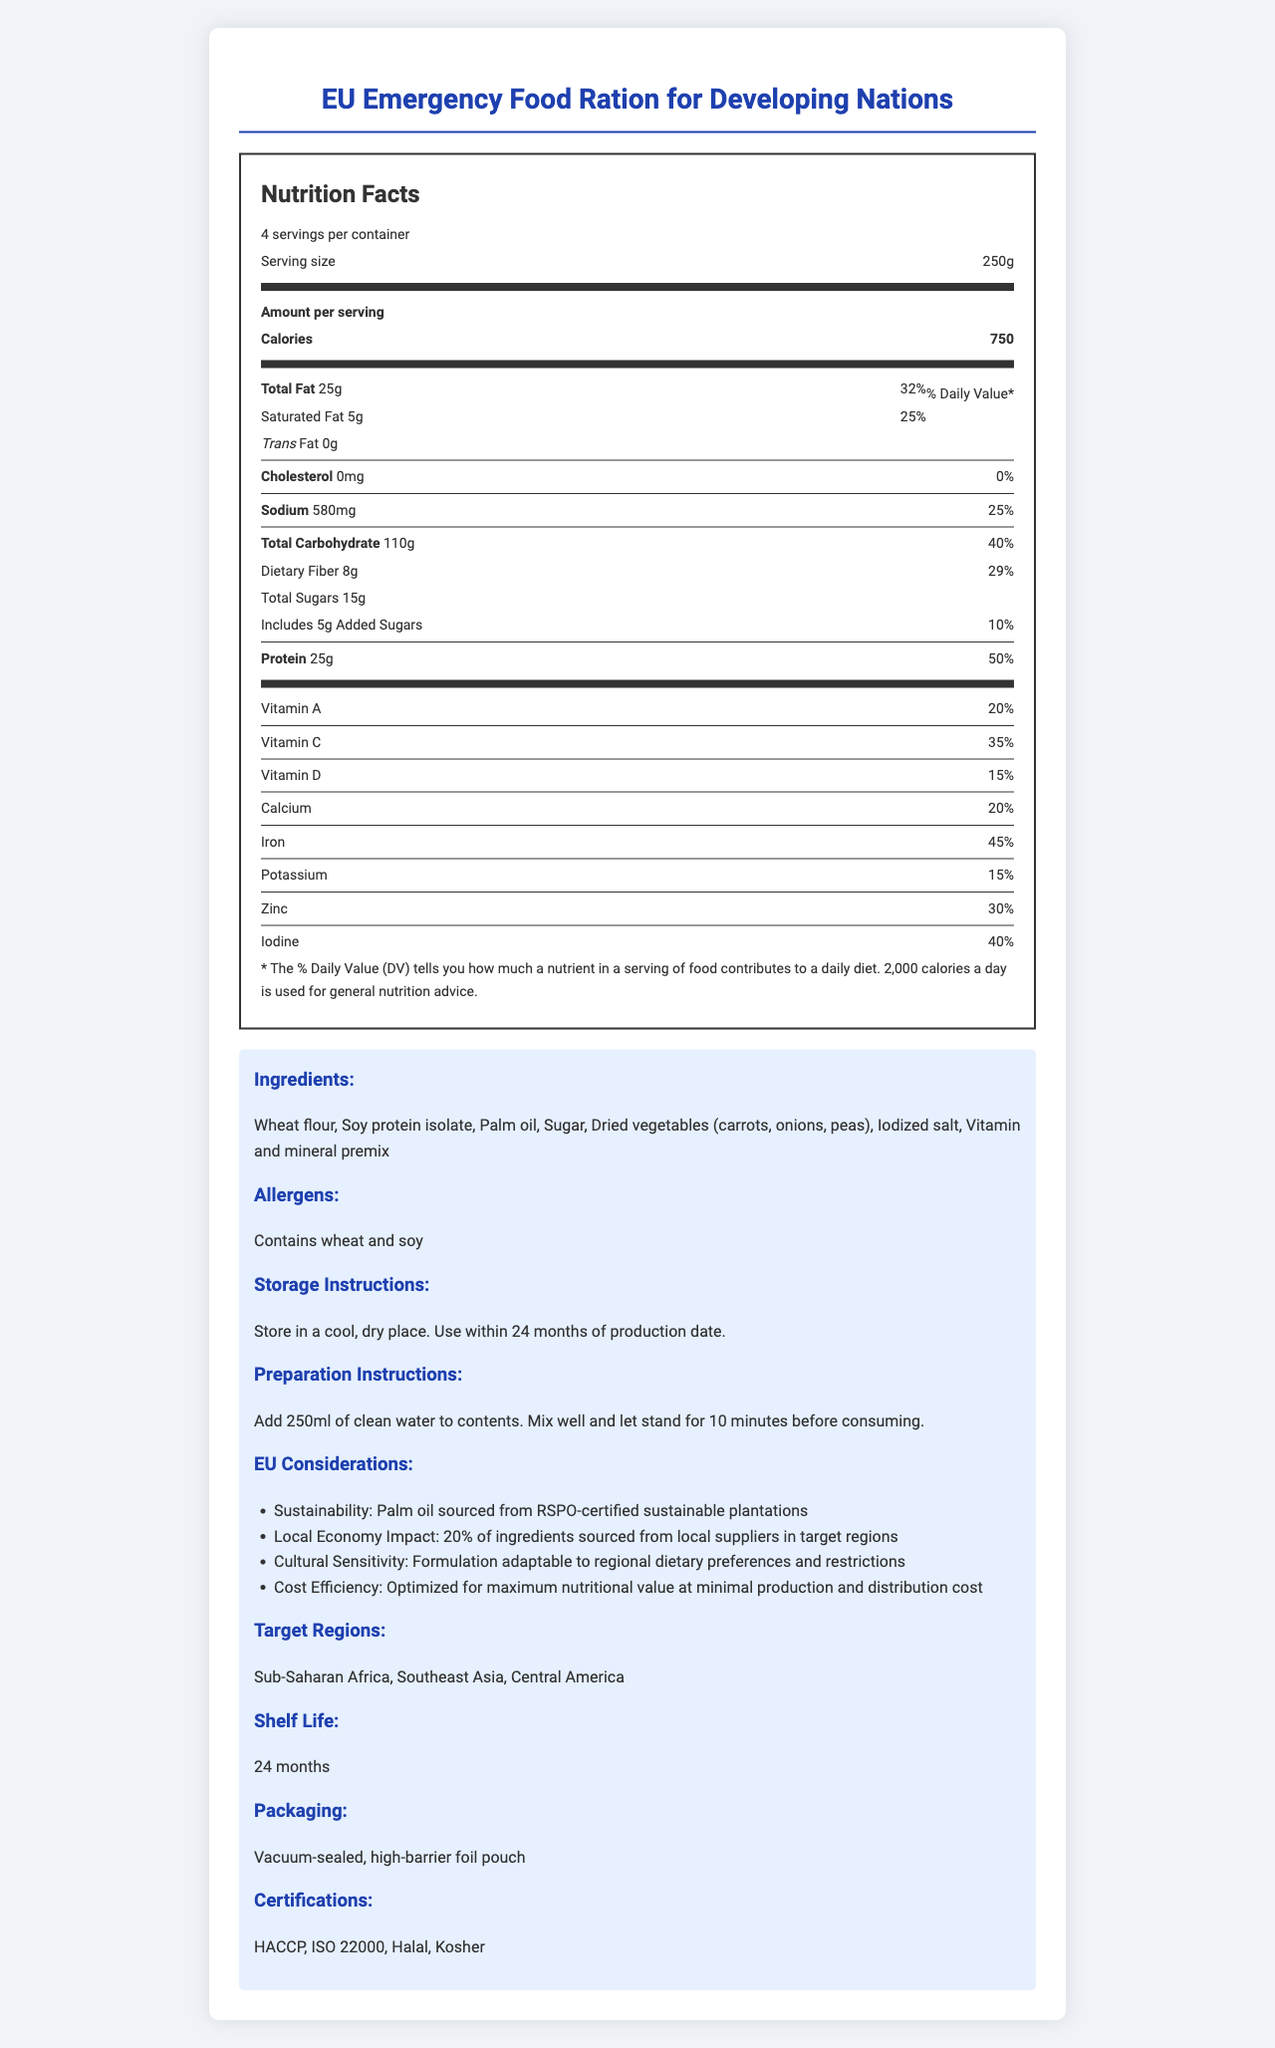what is the serving size of the EU Emergency Food Ration? The serving size is mentioned at the top of the nutrition label as "Serving size 250g".
Answer: 250g How many servings are there per container? This information is provided right at the beginning under the product name, indicating "4 servings per container".
Answer: 4 How much protein is there in one serving, and what is its % Daily Value? The nutrition label provides the amount of protein per serving as 25g and the daily value percentage as 50%.
Answer: 25g, 50% What is the amount of saturated fat per serving, and what is its % Daily Value? The saturated fat content per serving is listed as 5g with a daily value percentage of 25%.
Answer: 5g, 25% How much vitamin C does one serving contain? The amount of Vitamin C per serving is given as 35% in the nutrition facts section.
Answer: 35% Which vitamin has the highest % Daily Value in one serving of this food ration? A. Vitamin A B. Vitamin C C. Vitamin D D. Iron Iron has the highest % Daily Value at 45%, compared to Vitamin A (20%), Vitamin C (35%), and Vitamin D (15%).
Answer: D. Iron What is the % Daily Value of dietary fiber per serving? A. 10% B. 20% C. 29% D. 40% The % Daily Value for dietary fiber is provided as 29%.
Answer: C. 29% Does this product contain any trans fat? The label specifically states "Trans Fat 0g", indicating there is no trans fat in this product.
Answer: No Does this product contain any cholesterol? The amount of cholesterol per serving is noted as 0mg with a daily value of 0%, indicating the absence of cholesterol.
Answer: No Summarize the key information from the document. The detailed nutrition facts section outlines the nutrients and % Daily Values for each serving, while the additional information section highlights aspects related to ingredients, allergens, EU considerations, and other relevant details.
Answer: The document provides detailed nutrition facts and additional information about the EU Emergency Food Ration for Developing Nations. It includes serving size, servings per container, and various nutrient amounts and their daily values. The product contains substantial amounts of calories, protein, carbohydrates, and essential vitamins and minerals. It also lists ingredients, allergens, storage and preparation instructions, EU considerations for sustainability and local economy impact, target regions, shelf life, packaging, and certifications. How much sugar is added to this product per serving? The label mentions "Includes 5g Added Sugars" under the carbohydrate section.
Answer: 5g How much sodium is in one serving of the food ration? The amount of sodium per serving is listed as 580mg on the nutrition label.
Answer: 580mg What is the shelf life of this product? The shelf life of the EU Emergency Food Ration is stated as 24 months in the additional information section.
Answer: 24 months What is one local economic impact consideration mentioned for this product? One of the EU considerations mentions that 20% of the ingredients are sourced from local suppliers in target regions.
Answer: 20% of ingredients sourced from local suppliers in target regions What are the allergens present in this product? The allergens listed in the document are "Contains wheat and soy".
Answer: Wheat and soy Can the product ingredients satisfy a gluten-free diet? The product contains wheat flour, which means it is not suitable for a gluten-free diet.
Answer: No What specific certification ensures the safety of this food product? The food product is certified with HACCP among other certifications like ISO 22000, Halal, and Kosher. HACCP is specifically known for ensuring food safety.
Answer: HACCP Which regions are the target areas for this food ration? The target regions for this product are mentioned as Sub-Saharan Africa, Southeast Asia, and Central America.
Answer: Sub-Saharan Africa, Southeast Asia, Central America How should the product be prepared for consumption? The preparation instructions provided are to add 250ml of clean water, mix well, and let it stand for 10 minutes before consuming.
Answer: Add 250ml of clean water to contents. Mix well and let stand for 10 minutes before consuming. What is the purpose of the thick and thin lines in the nutrition label? The thick lines are used to delineate major sections like calories and nutrients, and thin lines are used to separate items within those sections.
Answer: To separate different sections of the nutrition information 